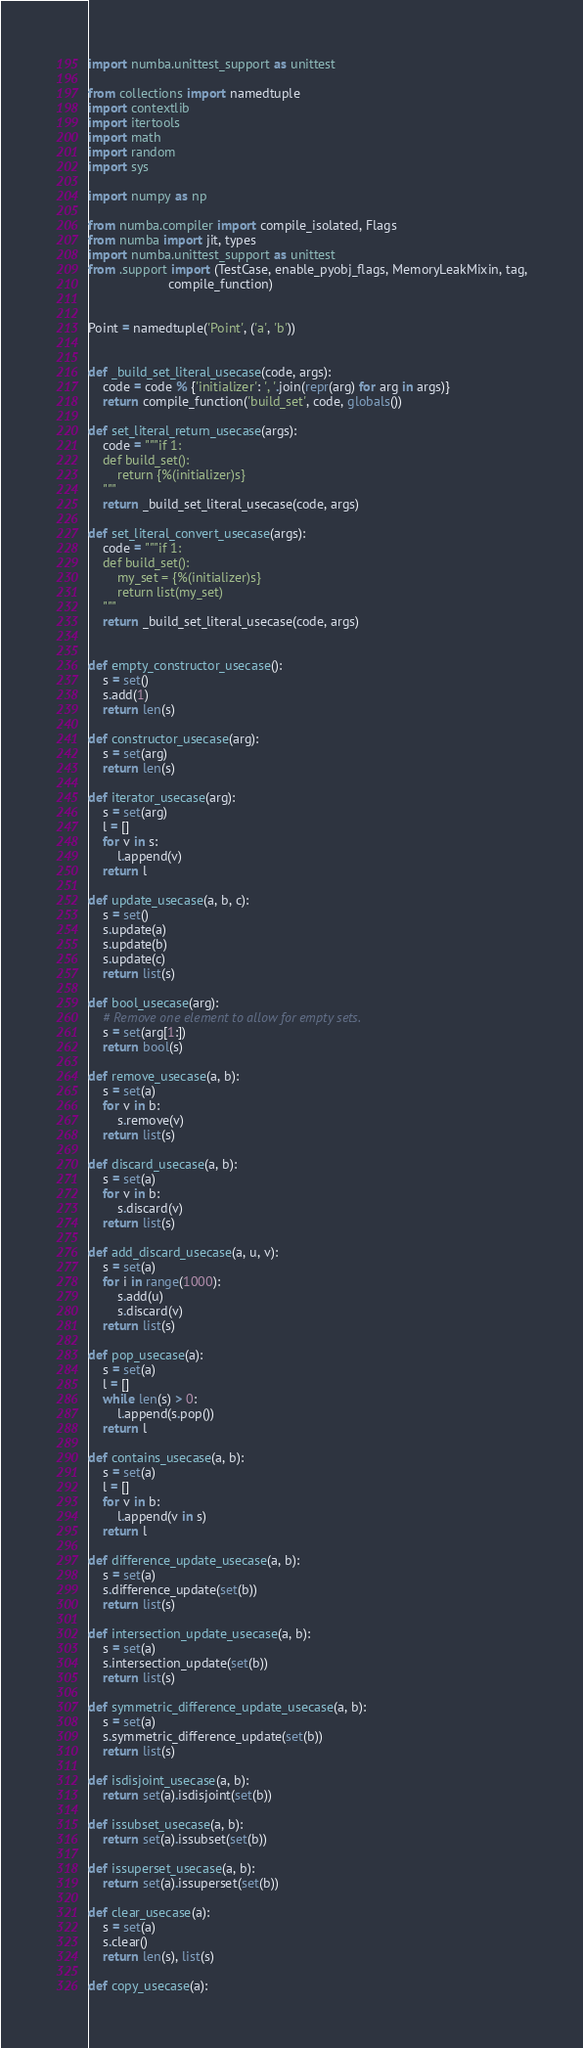<code> <loc_0><loc_0><loc_500><loc_500><_Python_>import numba.unittest_support as unittest

from collections import namedtuple
import contextlib
import itertools
import math
import random
import sys

import numpy as np

from numba.compiler import compile_isolated, Flags
from numba import jit, types
import numba.unittest_support as unittest
from .support import (TestCase, enable_pyobj_flags, MemoryLeakMixin, tag,
                      compile_function)


Point = namedtuple('Point', ('a', 'b'))


def _build_set_literal_usecase(code, args):
    code = code % {'initializer': ', '.join(repr(arg) for arg in args)}
    return compile_function('build_set', code, globals())

def set_literal_return_usecase(args):
    code = """if 1:
    def build_set():
        return {%(initializer)s}
    """
    return _build_set_literal_usecase(code, args)

def set_literal_convert_usecase(args):
    code = """if 1:
    def build_set():
        my_set = {%(initializer)s}
        return list(my_set)
    """
    return _build_set_literal_usecase(code, args)


def empty_constructor_usecase():
    s = set()
    s.add(1)
    return len(s)

def constructor_usecase(arg):
    s = set(arg)
    return len(s)

def iterator_usecase(arg):
    s = set(arg)
    l = []
    for v in s:
        l.append(v)
    return l

def update_usecase(a, b, c):
    s = set()
    s.update(a)
    s.update(b)
    s.update(c)
    return list(s)

def bool_usecase(arg):
    # Remove one element to allow for empty sets.
    s = set(arg[1:])
    return bool(s)

def remove_usecase(a, b):
    s = set(a)
    for v in b:
        s.remove(v)
    return list(s)

def discard_usecase(a, b):
    s = set(a)
    for v in b:
        s.discard(v)
    return list(s)

def add_discard_usecase(a, u, v):
    s = set(a)
    for i in range(1000):
        s.add(u)
        s.discard(v)
    return list(s)

def pop_usecase(a):
    s = set(a)
    l = []
    while len(s) > 0:
        l.append(s.pop())
    return l

def contains_usecase(a, b):
    s = set(a)
    l = []
    for v in b:
        l.append(v in s)
    return l

def difference_update_usecase(a, b):
    s = set(a)
    s.difference_update(set(b))
    return list(s)

def intersection_update_usecase(a, b):
    s = set(a)
    s.intersection_update(set(b))
    return list(s)

def symmetric_difference_update_usecase(a, b):
    s = set(a)
    s.symmetric_difference_update(set(b))
    return list(s)

def isdisjoint_usecase(a, b):
    return set(a).isdisjoint(set(b))

def issubset_usecase(a, b):
    return set(a).issubset(set(b))

def issuperset_usecase(a, b):
    return set(a).issuperset(set(b))

def clear_usecase(a):
    s = set(a)
    s.clear()
    return len(s), list(s)

def copy_usecase(a):</code> 